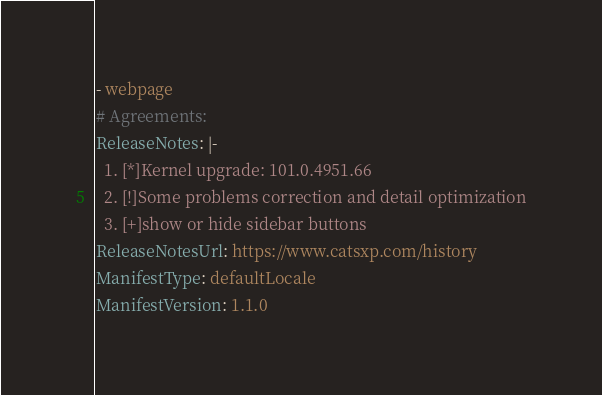<code> <loc_0><loc_0><loc_500><loc_500><_YAML_>- webpage
# Agreements: 
ReleaseNotes: |-
  1. [*]Kernel upgrade: 101.0.4951.66
  2. [!]Some problems correction and detail optimization
  3. [+]show or hide sidebar buttons
ReleaseNotesUrl: https://www.catsxp.com/history
ManifestType: defaultLocale
ManifestVersion: 1.1.0
</code> 